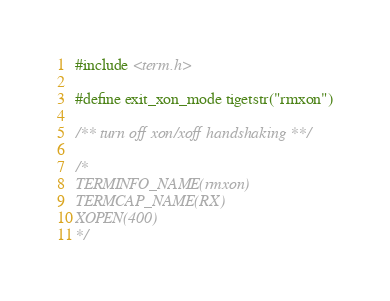Convert code to text. <code><loc_0><loc_0><loc_500><loc_500><_C_>#include <term.h>

#define exit_xon_mode tigetstr("rmxon")

/** turn off xon/xoff handshaking **/

/*
TERMINFO_NAME(rmxon)
TERMCAP_NAME(RX)
XOPEN(400)
*/
</code> 